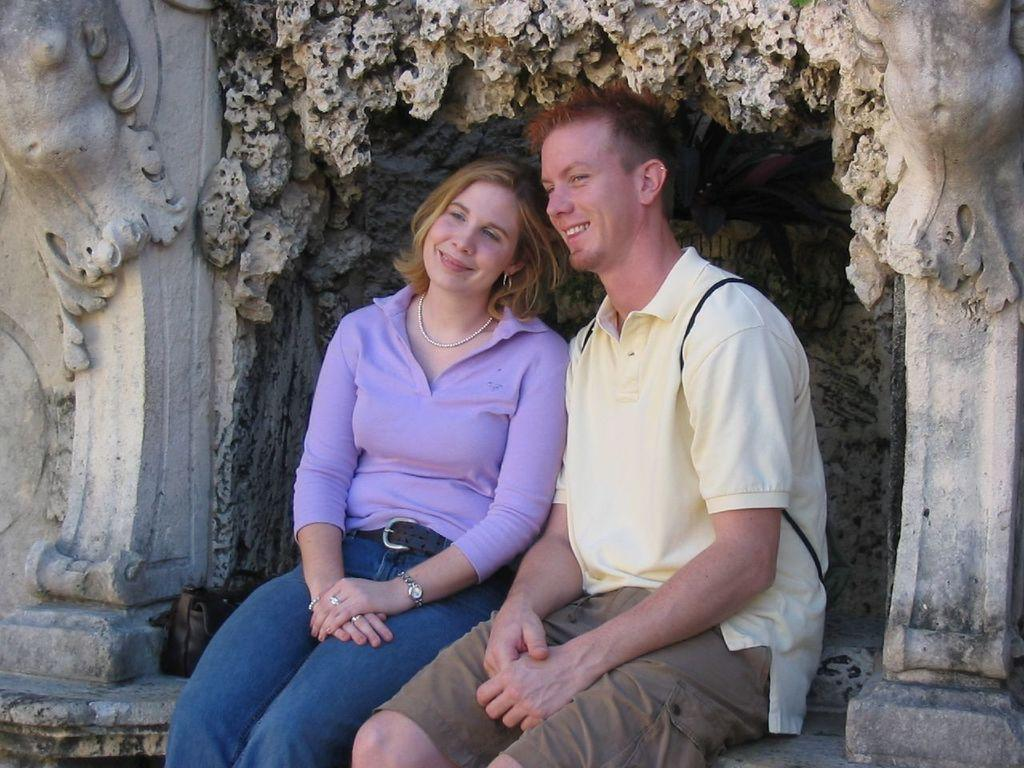How many people are in the image? There are two people in the image, a man and a woman. What are the man and the woman doing in the image? Both the man and the woman are sitting. What can be observed about the clothing of the man and the woman? The man and the woman are wearing clothes. What accessories is the woman wearing in the image? The woman is wearing a neck chain, earrings, a wrist watch, and a finger ring. Can you describe the wall design in the image? There is a wall design in the image, but no specific details are provided. How many leaves are on the tree in the image? There is no tree or leaves present in the image. What type of birds can be seen flying in the image? There are no birds present in the image. 